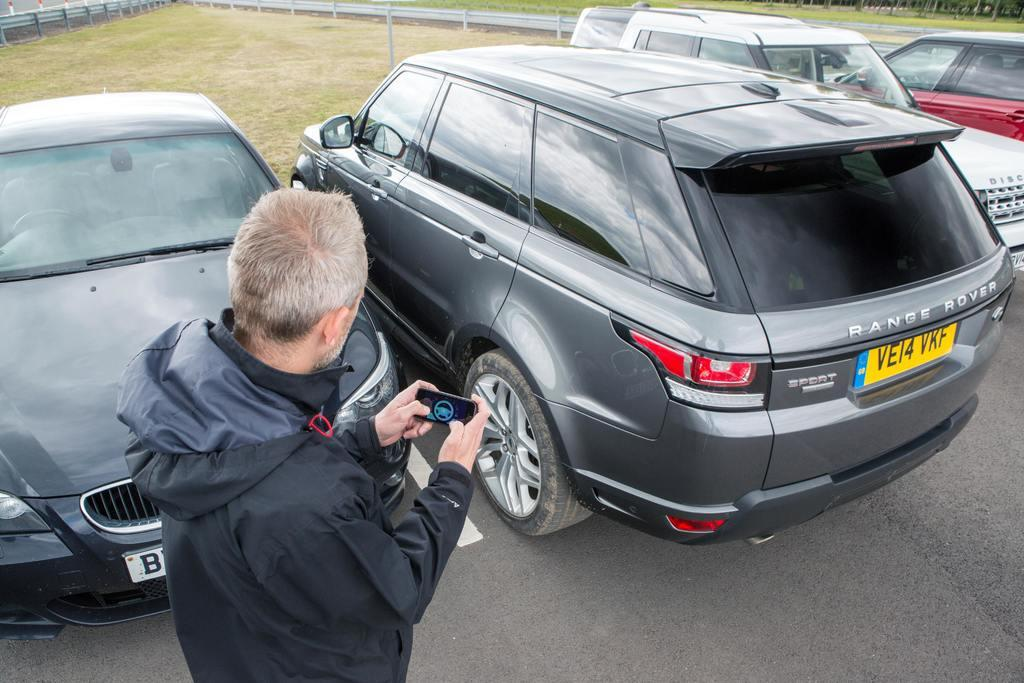Who is present in the image? There is a man in the image. What is the man holding in his hands? The man is holding a device in his hands. What can be seen on the road in the image? There are vehicles on the road in the image. What type of vegetation is visible in the image? There is grass visible in the image. What is visible in the background of the image? There are objects in the background of the image. What type of bird is flying over the man's head in the image? There is no bird visible in the image; only the man, the device, the vehicles, the grass, and the objects in the background are present. 